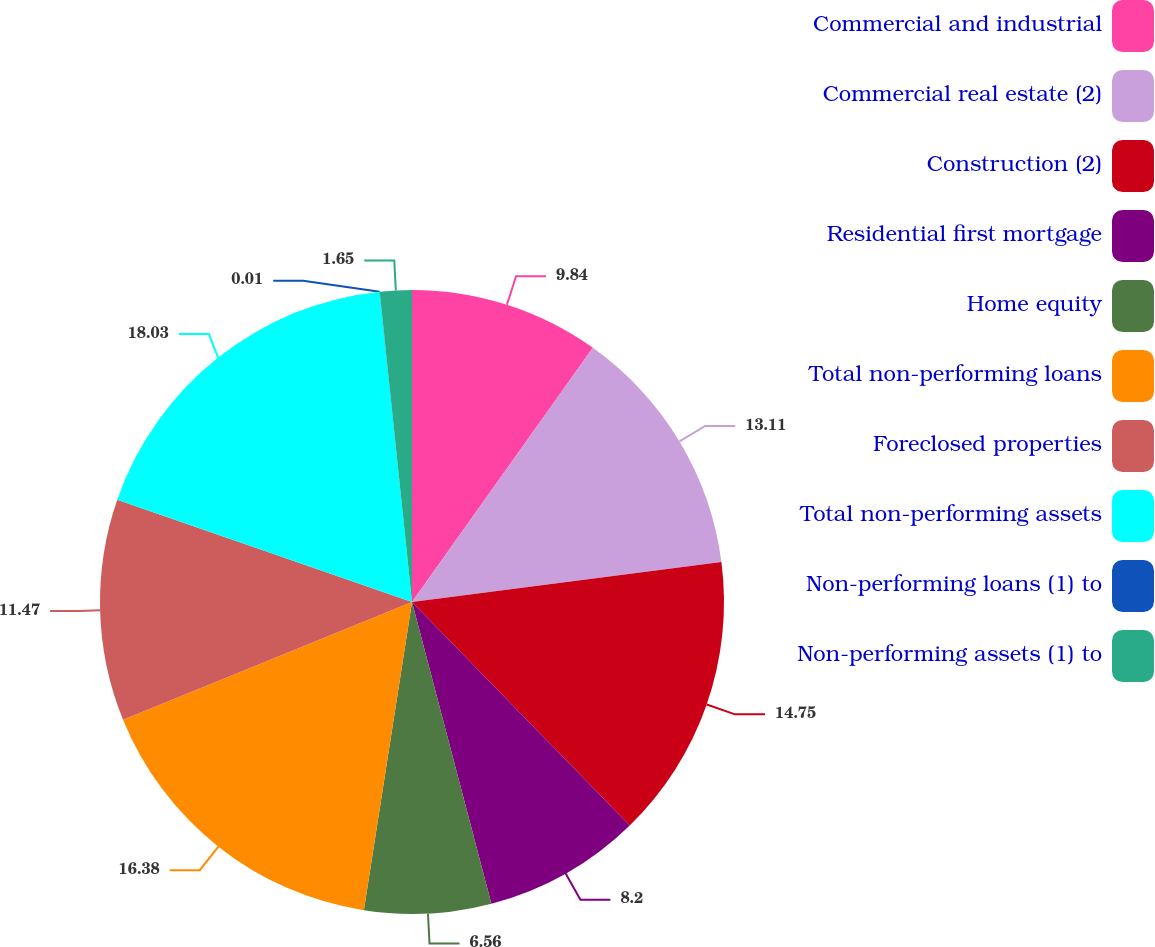Convert chart. <chart><loc_0><loc_0><loc_500><loc_500><pie_chart><fcel>Commercial and industrial<fcel>Commercial real estate (2)<fcel>Construction (2)<fcel>Residential first mortgage<fcel>Home equity<fcel>Total non-performing loans<fcel>Foreclosed properties<fcel>Total non-performing assets<fcel>Non-performing loans (1) to<fcel>Non-performing assets (1) to<nl><fcel>9.84%<fcel>13.11%<fcel>14.75%<fcel>8.2%<fcel>6.56%<fcel>16.38%<fcel>11.47%<fcel>18.02%<fcel>0.01%<fcel>1.65%<nl></chart> 